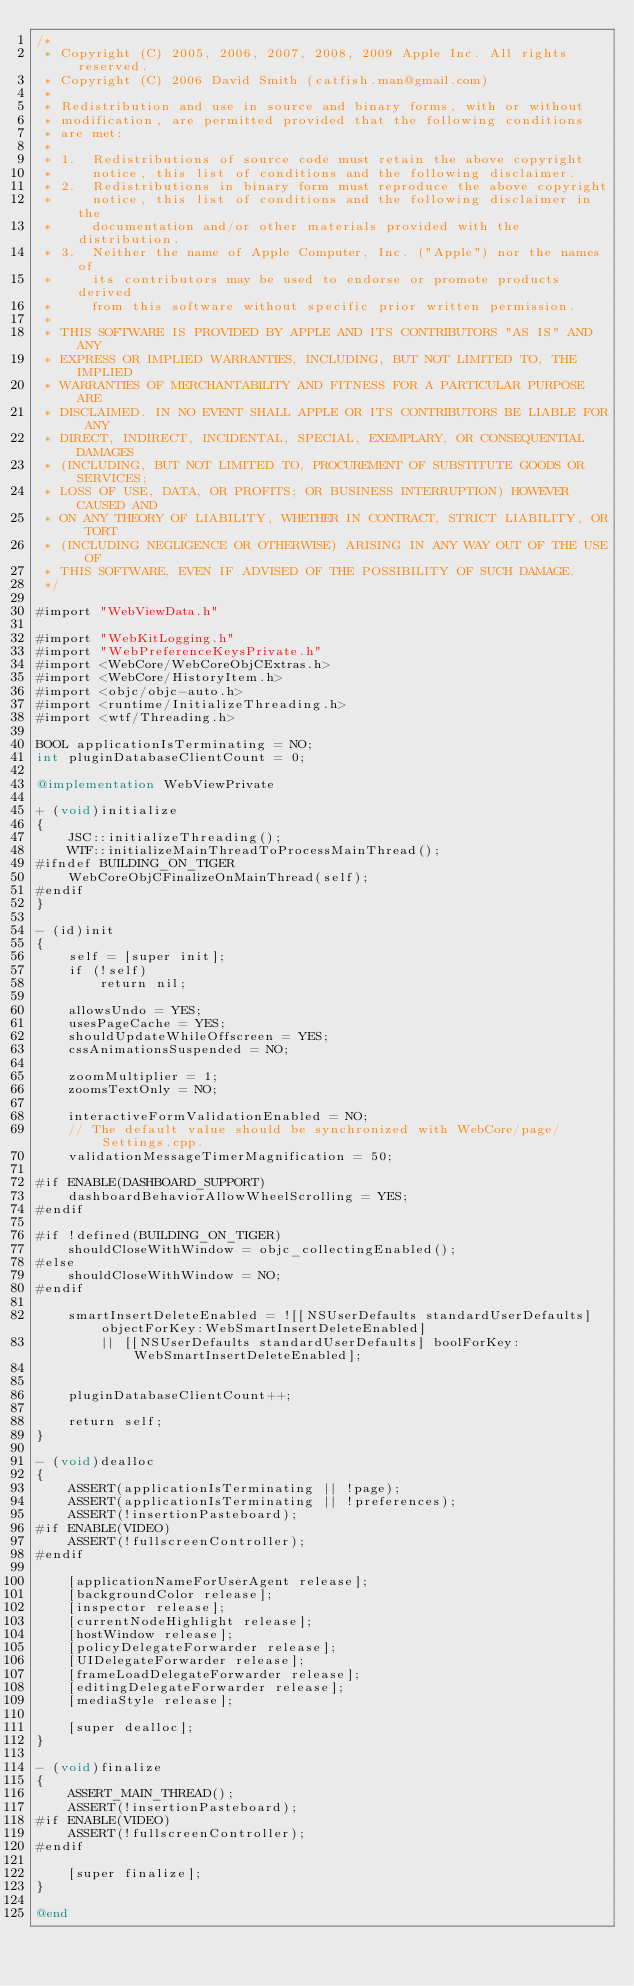<code> <loc_0><loc_0><loc_500><loc_500><_ObjectiveC_>/*
 * Copyright (C) 2005, 2006, 2007, 2008, 2009 Apple Inc. All rights reserved.
 * Copyright (C) 2006 David Smith (catfish.man@gmail.com)
 *
 * Redistribution and use in source and binary forms, with or without
 * modification, are permitted provided that the following conditions
 * are met:
 *
 * 1.  Redistributions of source code must retain the above copyright
 *     notice, this list of conditions and the following disclaimer. 
 * 2.  Redistributions in binary form must reproduce the above copyright
 *     notice, this list of conditions and the following disclaimer in the
 *     documentation and/or other materials provided with the distribution. 
 * 3.  Neither the name of Apple Computer, Inc. ("Apple") nor the names of
 *     its contributors may be used to endorse or promote products derived
 *     from this software without specific prior written permission. 
 *
 * THIS SOFTWARE IS PROVIDED BY APPLE AND ITS CONTRIBUTORS "AS IS" AND ANY
 * EXPRESS OR IMPLIED WARRANTIES, INCLUDING, BUT NOT LIMITED TO, THE IMPLIED
 * WARRANTIES OF MERCHANTABILITY AND FITNESS FOR A PARTICULAR PURPOSE ARE
 * DISCLAIMED. IN NO EVENT SHALL APPLE OR ITS CONTRIBUTORS BE LIABLE FOR ANY
 * DIRECT, INDIRECT, INCIDENTAL, SPECIAL, EXEMPLARY, OR CONSEQUENTIAL DAMAGES
 * (INCLUDING, BUT NOT LIMITED TO, PROCUREMENT OF SUBSTITUTE GOODS OR SERVICES;
 * LOSS OF USE, DATA, OR PROFITS; OR BUSINESS INTERRUPTION) HOWEVER CAUSED AND
 * ON ANY THEORY OF LIABILITY, WHETHER IN CONTRACT, STRICT LIABILITY, OR TORT
 * (INCLUDING NEGLIGENCE OR OTHERWISE) ARISING IN ANY WAY OUT OF THE USE OF
 * THIS SOFTWARE, EVEN IF ADVISED OF THE POSSIBILITY OF SUCH DAMAGE.
 */

#import "WebViewData.h"

#import "WebKitLogging.h"
#import "WebPreferenceKeysPrivate.h"
#import <WebCore/WebCoreObjCExtras.h>
#import <WebCore/HistoryItem.h>
#import <objc/objc-auto.h>
#import <runtime/InitializeThreading.h>
#import <wtf/Threading.h>

BOOL applicationIsTerminating = NO;
int pluginDatabaseClientCount = 0;

@implementation WebViewPrivate

+ (void)initialize
{
    JSC::initializeThreading();
    WTF::initializeMainThreadToProcessMainThread();
#ifndef BUILDING_ON_TIGER
    WebCoreObjCFinalizeOnMainThread(self);
#endif
}

- (id)init 
{
    self = [super init];
    if (!self)
        return nil;

    allowsUndo = YES;
    usesPageCache = YES;
    shouldUpdateWhileOffscreen = YES;
    cssAnimationsSuspended = NO;

    zoomMultiplier = 1;
    zoomsTextOnly = NO;

    interactiveFormValidationEnabled = NO;
    // The default value should be synchronized with WebCore/page/Settings.cpp.
    validationMessageTimerMagnification = 50;

#if ENABLE(DASHBOARD_SUPPORT)
    dashboardBehaviorAllowWheelScrolling = YES;
#endif

#if !defined(BUILDING_ON_TIGER)
    shouldCloseWithWindow = objc_collectingEnabled();
#else
    shouldCloseWithWindow = NO;
#endif

    smartInsertDeleteEnabled = ![[NSUserDefaults standardUserDefaults] objectForKey:WebSmartInsertDeleteEnabled]
        || [[NSUserDefaults standardUserDefaults] boolForKey:WebSmartInsertDeleteEnabled];


    pluginDatabaseClientCount++;

    return self;
}

- (void)dealloc
{    
    ASSERT(applicationIsTerminating || !page);
    ASSERT(applicationIsTerminating || !preferences);
    ASSERT(!insertionPasteboard);
#if ENABLE(VIDEO)
    ASSERT(!fullscreenController);
#endif

    [applicationNameForUserAgent release];
    [backgroundColor release];
    [inspector release];
    [currentNodeHighlight release];
    [hostWindow release];
    [policyDelegateForwarder release];
    [UIDelegateForwarder release];
    [frameLoadDelegateForwarder release];
    [editingDelegateForwarder release];
    [mediaStyle release];

    [super dealloc];
}

- (void)finalize
{
    ASSERT_MAIN_THREAD();
    ASSERT(!insertionPasteboard);
#if ENABLE(VIDEO)
    ASSERT(!fullscreenController);
#endif

    [super finalize];
}

@end
</code> 